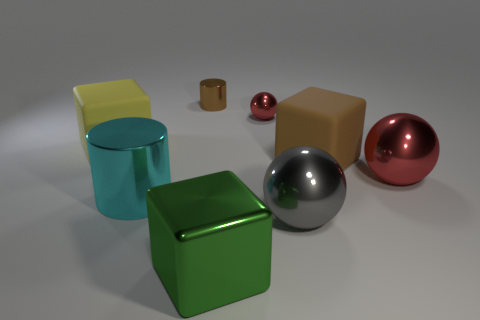The metallic thing that is left of the large green object and right of the cyan metal thing has what shape?
Provide a succinct answer. Cylinder. Are there any tiny metal things of the same color as the shiny block?
Ensure brevity in your answer.  No. What is the color of the tiny cylinder that is behind the metal sphere that is left of the large gray shiny thing?
Your answer should be compact. Brown. There is a metallic sphere in front of the cylinder that is in front of the matte thing right of the small brown cylinder; how big is it?
Your answer should be compact. Large. Are the small brown cylinder and the big sphere that is on the right side of the brown block made of the same material?
Give a very brief answer. Yes. There is a gray ball that is the same material as the large green thing; what is its size?
Offer a very short reply. Large. Is there a big green thing of the same shape as the big red thing?
Your response must be concise. No. How many objects are either objects that are on the right side of the tiny brown shiny cylinder or small red rubber cubes?
Offer a terse response. 5. What is the size of the thing that is the same color as the tiny cylinder?
Make the answer very short. Large. Do the thing that is on the left side of the large cyan metallic cylinder and the ball on the left side of the gray ball have the same color?
Your response must be concise. No. 